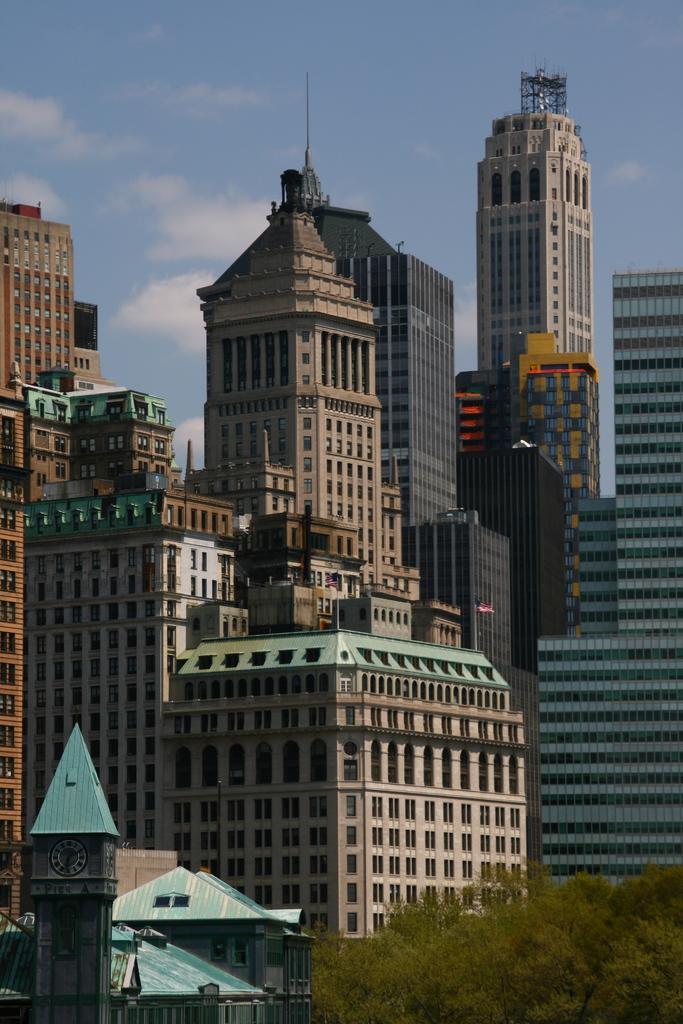In one or two sentences, can you explain what this image depicts? In this image we can see buildings and trees. This is clock tower with clock. Background we can see the sky. These are clouds.  